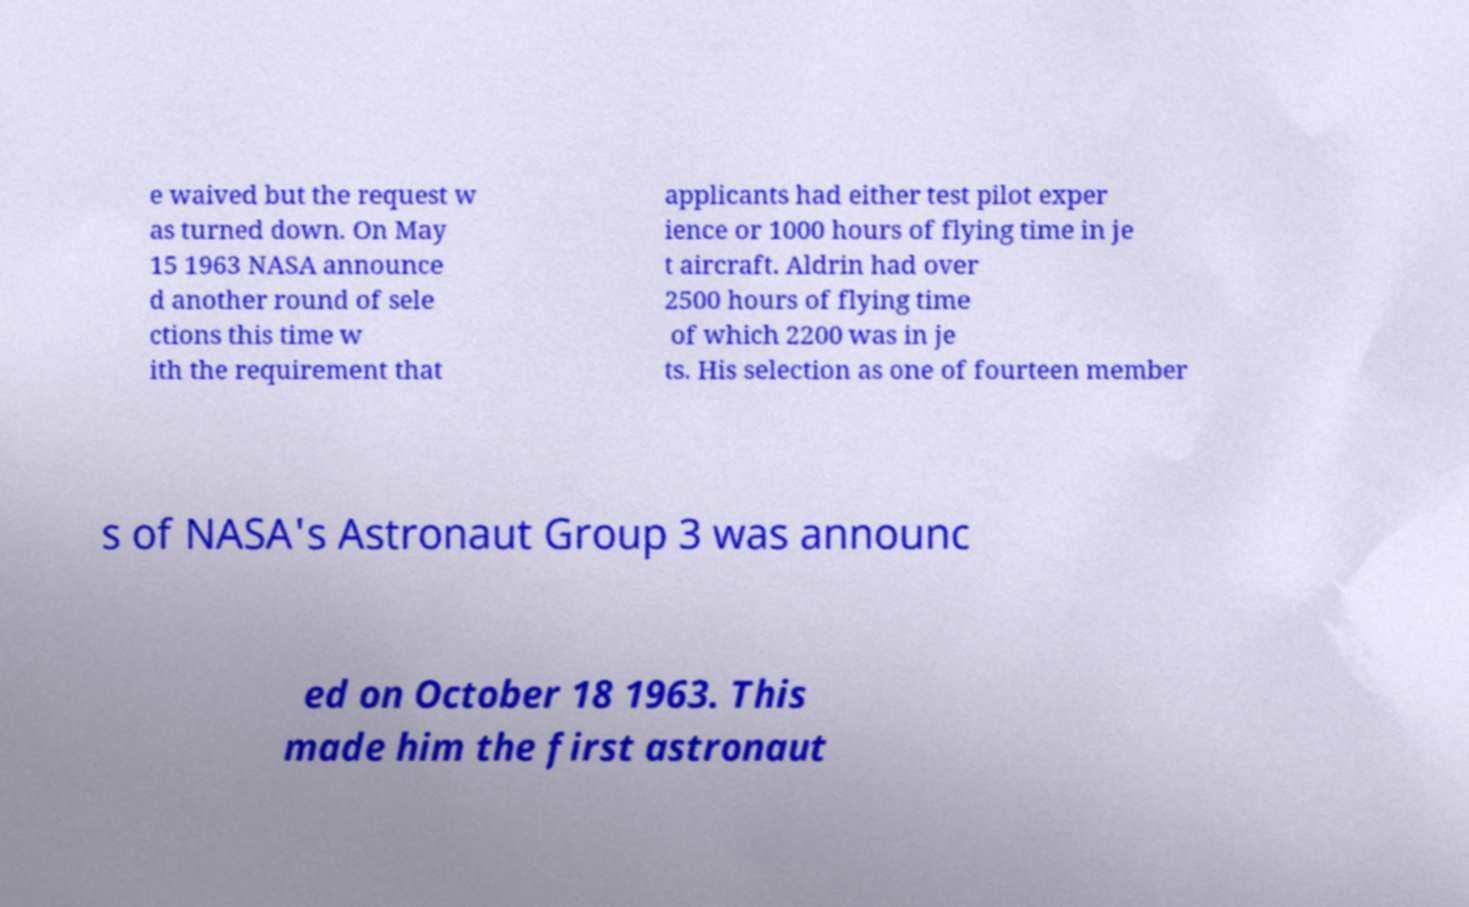Please identify and transcribe the text found in this image. e waived but the request w as turned down. On May 15 1963 NASA announce d another round of sele ctions this time w ith the requirement that applicants had either test pilot exper ience or 1000 hours of flying time in je t aircraft. Aldrin had over 2500 hours of flying time of which 2200 was in je ts. His selection as one of fourteen member s of NASA's Astronaut Group 3 was announc ed on October 18 1963. This made him the first astronaut 